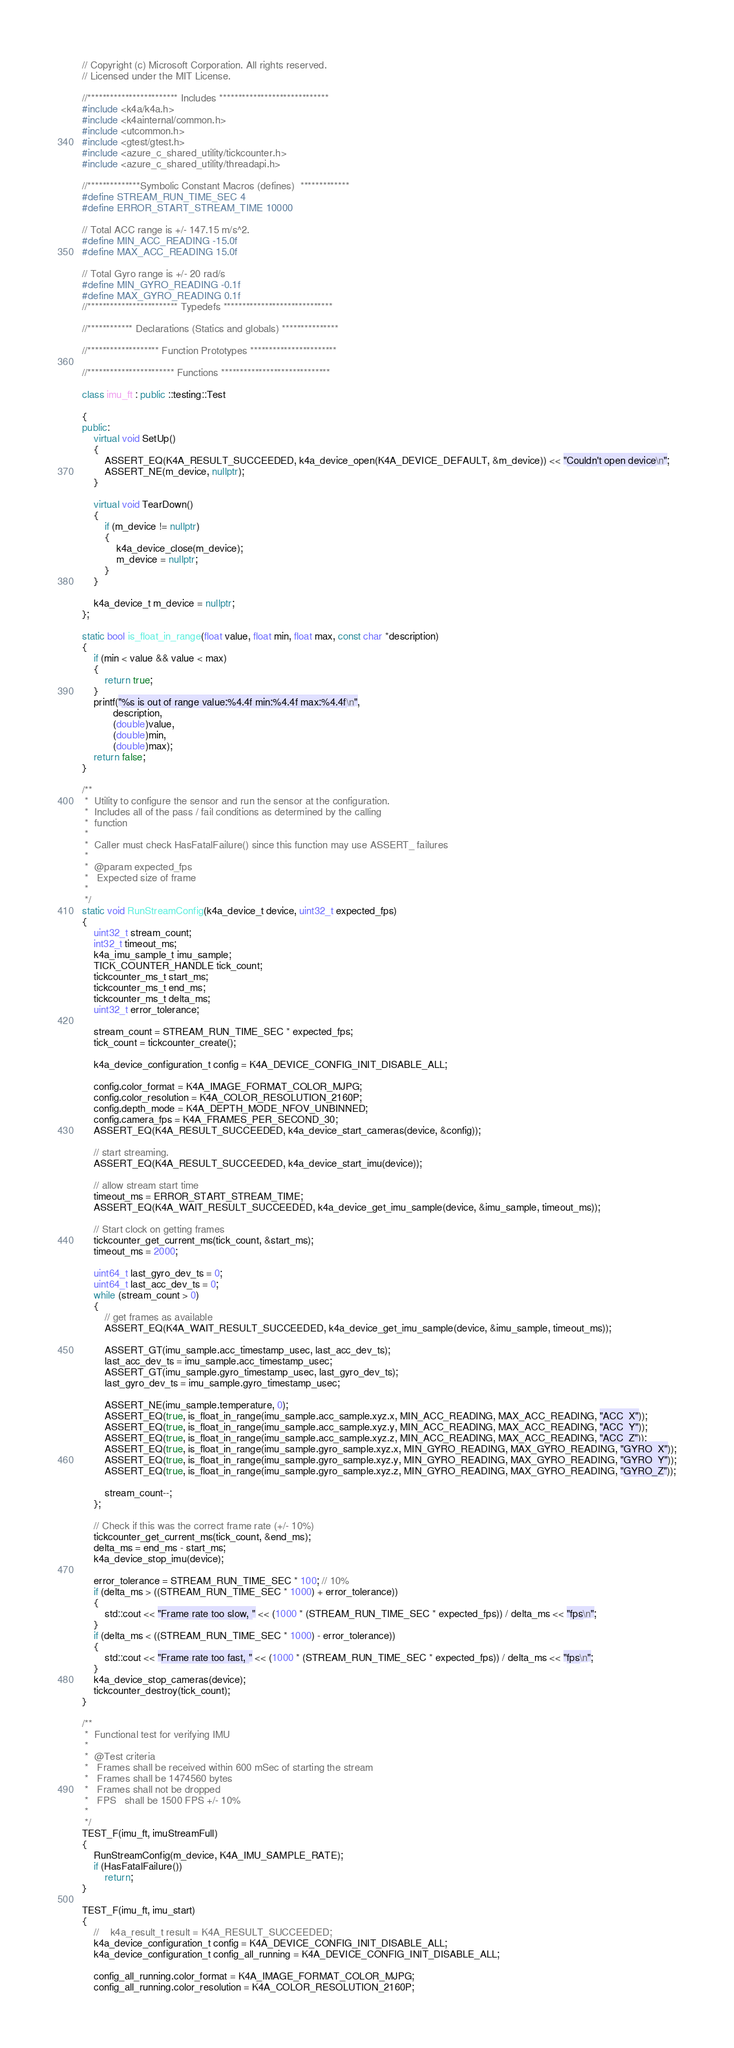Convert code to text. <code><loc_0><loc_0><loc_500><loc_500><_C++_>// Copyright (c) Microsoft Corporation. All rights reserved.
// Licensed under the MIT License.

//************************ Includes *****************************
#include <k4a/k4a.h>
#include <k4ainternal/common.h>
#include <utcommon.h>
#include <gtest/gtest.h>
#include <azure_c_shared_utility/tickcounter.h>
#include <azure_c_shared_utility/threadapi.h>

//**************Symbolic Constant Macros (defines)  *************
#define STREAM_RUN_TIME_SEC 4
#define ERROR_START_STREAM_TIME 10000

// Total ACC range is +/- 147.15 m/s^2.
#define MIN_ACC_READING -15.0f
#define MAX_ACC_READING 15.0f

// Total Gyro range is +/- 20 rad/s
#define MIN_GYRO_READING -0.1f
#define MAX_GYRO_READING 0.1f
//************************ Typedefs *****************************

//************ Declarations (Statics and globals) ***************

//******************* Function Prototypes ***********************

//*********************** Functions *****************************

class imu_ft : public ::testing::Test

{
public:
    virtual void SetUp()
    {
        ASSERT_EQ(K4A_RESULT_SUCCEEDED, k4a_device_open(K4A_DEVICE_DEFAULT, &m_device)) << "Couldn't open device\n";
        ASSERT_NE(m_device, nullptr);
    }

    virtual void TearDown()
    {
        if (m_device != nullptr)
        {
            k4a_device_close(m_device);
            m_device = nullptr;
        }
    }

    k4a_device_t m_device = nullptr;
};

static bool is_float_in_range(float value, float min, float max, const char *description)
{
    if (min < value && value < max)
    {
        return true;
    }
    printf("%s is out of range value:%4.4f min:%4.4f max:%4.4f\n",
           description,
           (double)value,
           (double)min,
           (double)max);
    return false;
}

/**
 *  Utility to configure the sensor and run the sensor at the configuration.
 *  Includes all of the pass / fail conditions as determined by the calling
 *  function
 *
 *  Caller must check HasFatalFailure() since this function may use ASSERT_ failures
 *
 *  @param expected_fps
 *   Expected size of frame
 *
 */
static void RunStreamConfig(k4a_device_t device, uint32_t expected_fps)
{
    uint32_t stream_count;
    int32_t timeout_ms;
    k4a_imu_sample_t imu_sample;
    TICK_COUNTER_HANDLE tick_count;
    tickcounter_ms_t start_ms;
    tickcounter_ms_t end_ms;
    tickcounter_ms_t delta_ms;
    uint32_t error_tolerance;

    stream_count = STREAM_RUN_TIME_SEC * expected_fps;
    tick_count = tickcounter_create();

    k4a_device_configuration_t config = K4A_DEVICE_CONFIG_INIT_DISABLE_ALL;

    config.color_format = K4A_IMAGE_FORMAT_COLOR_MJPG;
    config.color_resolution = K4A_COLOR_RESOLUTION_2160P;
    config.depth_mode = K4A_DEPTH_MODE_NFOV_UNBINNED;
    config.camera_fps = K4A_FRAMES_PER_SECOND_30;
    ASSERT_EQ(K4A_RESULT_SUCCEEDED, k4a_device_start_cameras(device, &config));

    // start streaming.
    ASSERT_EQ(K4A_RESULT_SUCCEEDED, k4a_device_start_imu(device));

    // allow stream start time
    timeout_ms = ERROR_START_STREAM_TIME;
    ASSERT_EQ(K4A_WAIT_RESULT_SUCCEEDED, k4a_device_get_imu_sample(device, &imu_sample, timeout_ms));

    // Start clock on getting frames
    tickcounter_get_current_ms(tick_count, &start_ms);
    timeout_ms = 2000;

    uint64_t last_gyro_dev_ts = 0;
    uint64_t last_acc_dev_ts = 0;
    while (stream_count > 0)
    {
        // get frames as available
        ASSERT_EQ(K4A_WAIT_RESULT_SUCCEEDED, k4a_device_get_imu_sample(device, &imu_sample, timeout_ms));

        ASSERT_GT(imu_sample.acc_timestamp_usec, last_acc_dev_ts);
        last_acc_dev_ts = imu_sample.acc_timestamp_usec;
        ASSERT_GT(imu_sample.gyro_timestamp_usec, last_gyro_dev_ts);
        last_gyro_dev_ts = imu_sample.gyro_timestamp_usec;

        ASSERT_NE(imu_sample.temperature, 0);
        ASSERT_EQ(true, is_float_in_range(imu_sample.acc_sample.xyz.x, MIN_ACC_READING, MAX_ACC_READING, "ACC_X"));
        ASSERT_EQ(true, is_float_in_range(imu_sample.acc_sample.xyz.y, MIN_ACC_READING, MAX_ACC_READING, "ACC_Y"));
        ASSERT_EQ(true, is_float_in_range(imu_sample.acc_sample.xyz.z, MIN_ACC_READING, MAX_ACC_READING, "ACC_Z"));
        ASSERT_EQ(true, is_float_in_range(imu_sample.gyro_sample.xyz.x, MIN_GYRO_READING, MAX_GYRO_READING, "GYRO_X"));
        ASSERT_EQ(true, is_float_in_range(imu_sample.gyro_sample.xyz.y, MIN_GYRO_READING, MAX_GYRO_READING, "GYRO_Y"));
        ASSERT_EQ(true, is_float_in_range(imu_sample.gyro_sample.xyz.z, MIN_GYRO_READING, MAX_GYRO_READING, "GYRO_Z"));

        stream_count--;
    };

    // Check if this was the correct frame rate (+/- 10%)
    tickcounter_get_current_ms(tick_count, &end_ms);
    delta_ms = end_ms - start_ms;
    k4a_device_stop_imu(device);

    error_tolerance = STREAM_RUN_TIME_SEC * 100; // 10%
    if (delta_ms > ((STREAM_RUN_TIME_SEC * 1000) + error_tolerance))
    {
        std::cout << "Frame rate too slow, " << (1000 * (STREAM_RUN_TIME_SEC * expected_fps)) / delta_ms << "fps\n";
    }
    if (delta_ms < ((STREAM_RUN_TIME_SEC * 1000) - error_tolerance))
    {
        std::cout << "Frame rate too fast, " << (1000 * (STREAM_RUN_TIME_SEC * expected_fps)) / delta_ms << "fps\n";
    }
    k4a_device_stop_cameras(device);
    tickcounter_destroy(tick_count);
}

/**
 *  Functional test for verifying IMU
 *
 *  @Test criteria
 *   Frames shall be received within 600 mSec of starting the stream
 *   Frames shall be 1474560 bytes
 *   Frames shall not be dropped
 *   FPS   shall be 1500 FPS +/- 10%
 *
 */
TEST_F(imu_ft, imuStreamFull)
{
    RunStreamConfig(m_device, K4A_IMU_SAMPLE_RATE);
    if (HasFatalFailure())
        return;
}

TEST_F(imu_ft, imu_start)
{
    //    k4a_result_t result = K4A_RESULT_SUCCEEDED;
    k4a_device_configuration_t config = K4A_DEVICE_CONFIG_INIT_DISABLE_ALL;
    k4a_device_configuration_t config_all_running = K4A_DEVICE_CONFIG_INIT_DISABLE_ALL;

    config_all_running.color_format = K4A_IMAGE_FORMAT_COLOR_MJPG;
    config_all_running.color_resolution = K4A_COLOR_RESOLUTION_2160P;</code> 